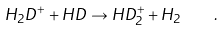<formula> <loc_0><loc_0><loc_500><loc_500>H _ { 2 } D ^ { + } + H D \rightarrow H D _ { 2 } ^ { + } + H _ { 2 } \quad .</formula> 